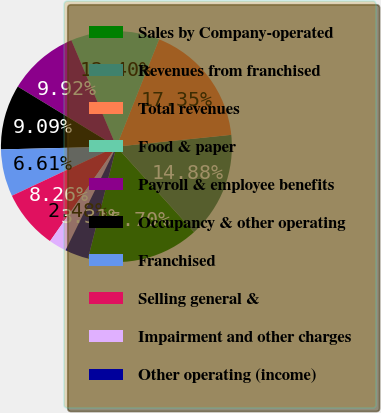Convert chart. <chart><loc_0><loc_0><loc_500><loc_500><pie_chart><fcel>Sales by Company-operated<fcel>Revenues from franchised<fcel>Total revenues<fcel>Food & paper<fcel>Payroll & employee benefits<fcel>Occupancy & other operating<fcel>Franchised<fcel>Selling general &<fcel>Impairment and other charges<fcel>Other operating (income)<nl><fcel>15.7%<fcel>14.88%<fcel>17.35%<fcel>12.4%<fcel>9.92%<fcel>9.09%<fcel>6.61%<fcel>8.26%<fcel>2.48%<fcel>3.31%<nl></chart> 